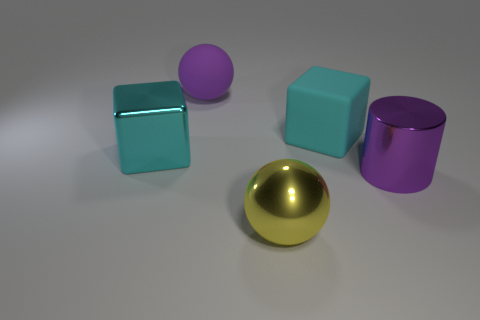Add 1 balls. How many objects exist? 6 Subtract all blocks. How many objects are left? 3 Add 3 yellow spheres. How many yellow spheres exist? 4 Subtract 0 gray spheres. How many objects are left? 5 Subtract all big blue metal objects. Subtract all purple cylinders. How many objects are left? 4 Add 5 cyan matte things. How many cyan matte things are left? 6 